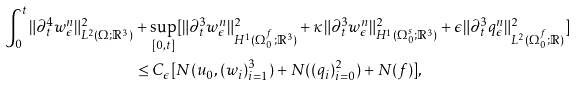Convert formula to latex. <formula><loc_0><loc_0><loc_500><loc_500>\int _ { 0 } ^ { t } \| \partial _ { t } ^ { 4 } w ^ { n } _ { \epsilon } \| ^ { 2 } _ { L ^ { 2 } ( \Omega ; { \mathbb { R } } ^ { 3 } ) } & + \sup _ { [ 0 , t ] } [ \| \partial _ { t } ^ { 3 } { w ^ { n } _ { \epsilon } } \| ^ { 2 } _ { H ^ { 1 } ( \Omega _ { 0 } ^ { f } ; { \mathbb { R } } ^ { 3 } ) } + \kappa \| \partial _ { t } ^ { 3 } { w ^ { n } _ { \epsilon } } \| ^ { 2 } _ { H ^ { 1 } ( \Omega _ { 0 } ^ { s } ; { \mathbb { R } } ^ { 3 } ) } + \epsilon \| \partial _ { t } ^ { 3 } { q ^ { n } _ { \epsilon } } \| ^ { 2 } _ { L ^ { 2 } ( \Omega _ { 0 } ^ { f } ; { \mathbb { R } } ) } ] \\ & \leq C _ { \epsilon } [ N ( u _ { 0 } , ( w _ { i } ) _ { i = 1 } ^ { 3 } ) + N ( ( q _ { i } ) _ { i = 0 } ^ { 2 } ) + N ( f ) ] ,</formula> 